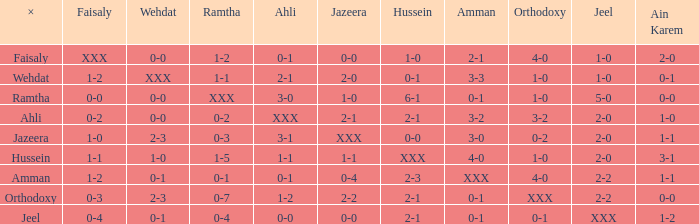When faisaly is 0-0, what does x represent? Ramtha. 